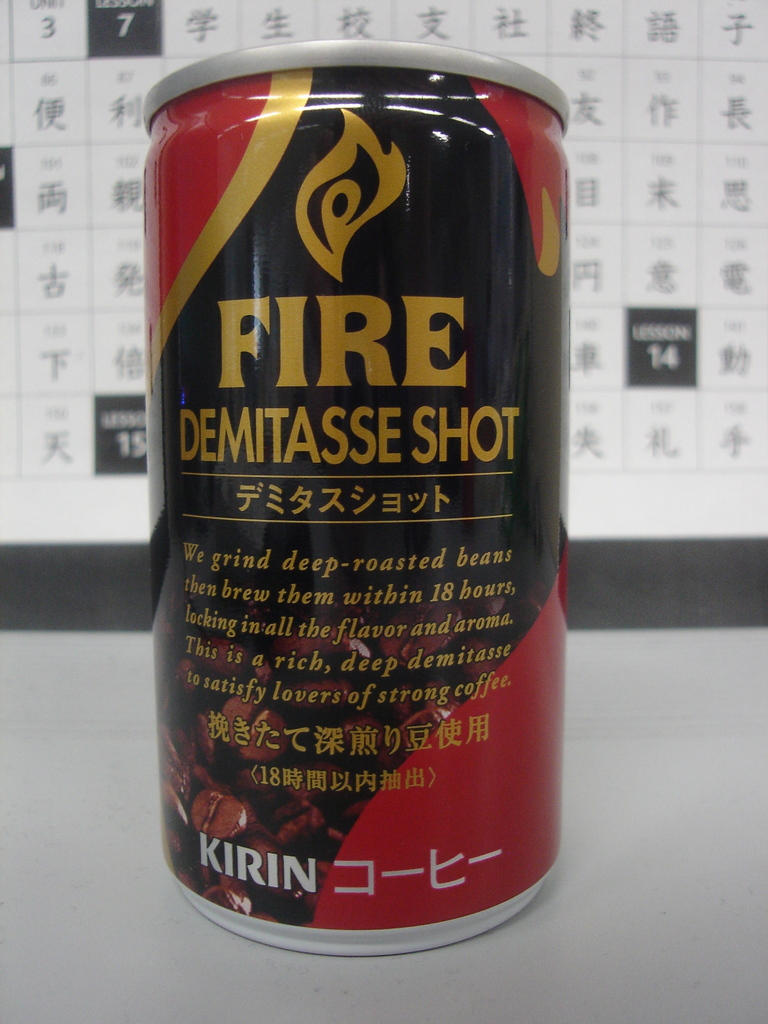Provide a one-sentence caption for the provided image. A can of Kirin's Fire Demitasse Shot, a rich and deep coffee brewed from deep-roasted beans within 18 hours to lock in all the flavor and aroma, catering to those who appreciate a strong coffee experience. 